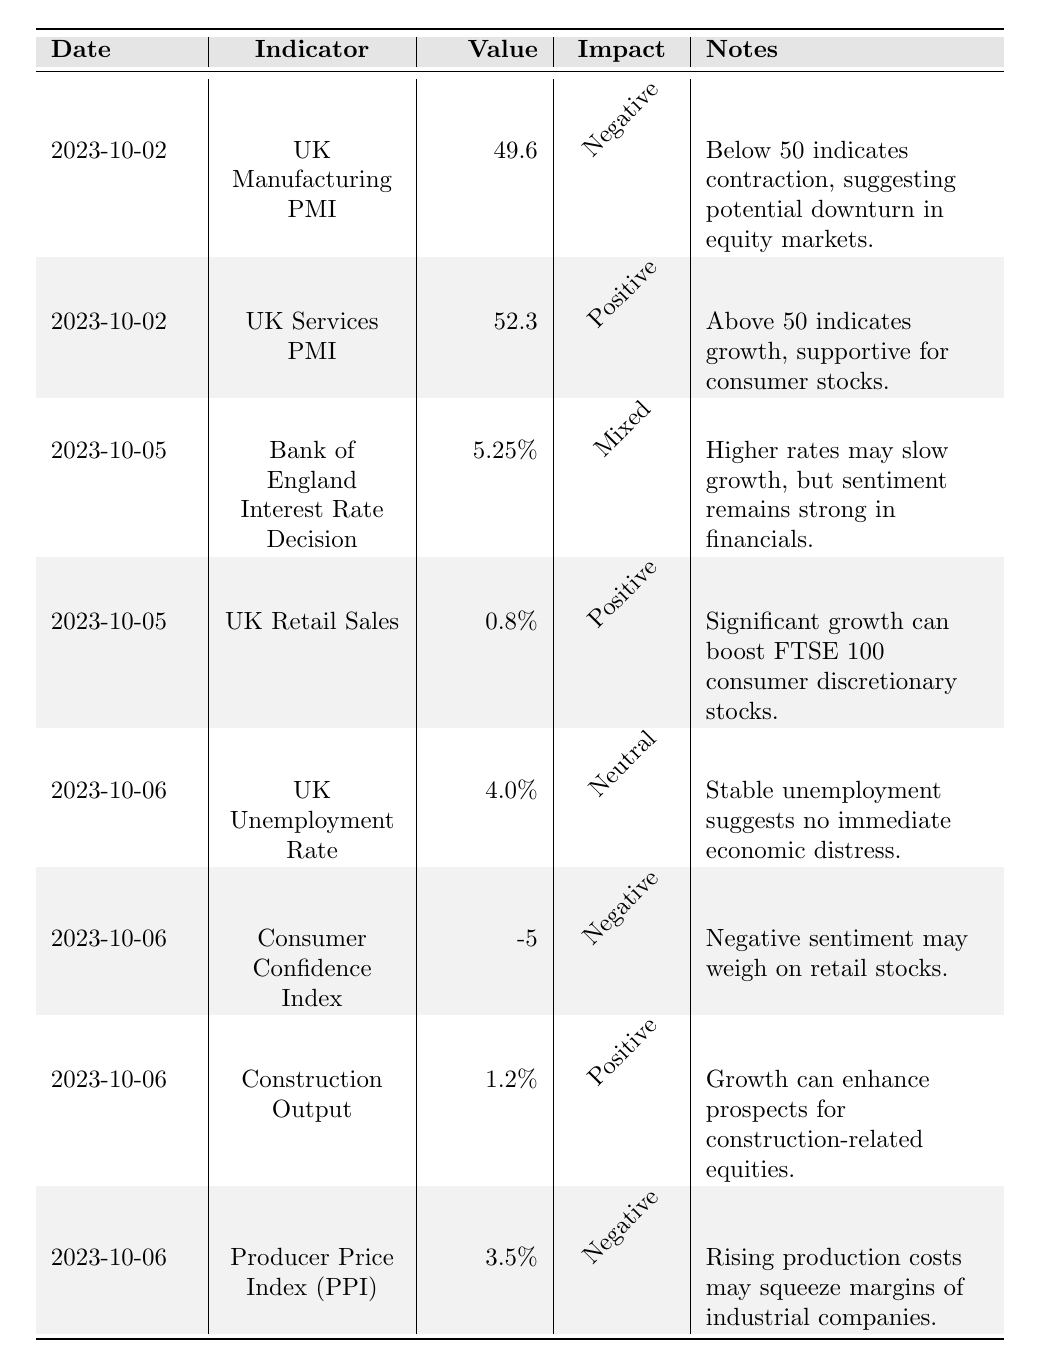What is the value of the UK Manufacturing PMI on 2023-10-02? The table shows the entry for the UK Manufacturing PMI on the date of 2023-10-02, which lists the value as 49.6.
Answer: 49.6 What impact is associated with the UK Services PMI? The table specifies that the UK Services PMI, recorded at a value of 52.3, has a positive impact.
Answer: Positive How does the UK Retail Sales figure affect the market sentiment? The value for UK Retail Sales is recorded at 0.8%, and the notes indicate this is a significant growth which can boost consumer discretionary stocks, suggesting a positive sentiment.
Answer: Positive Is the Consumer Confidence Index above zero? The Consumer Confidence Index is recorded at -5, which is below zero, indicating negative sentiment.
Answer: No What is the average value of the unemployment rate and the Producer Price Index? The unemployment rate is 4.0% and the Producer Price Index is 3.5%; to find the average, sum the two values (4.0 + 3.5) = 7.5, then divide by 2, resulting in 7.5/2 = 3.75.
Answer: 3.75 Which indicators show a positive impact on the market? The table lists the UK Services PMI, UK Retail Sales, and Construction Output, each with a positive impact noted. This means these three indicators are supportive for certain market sectors.
Answer: UK Services PMI, UK Retail Sales, Construction Output What is the relationship between the UK Manufacturing PMI and the equity markets? The table notes that the UK Manufacturing PMI value of 49.6 indicates contraction (below 50), suggesting a potential downturn in equity markets, indicating a negative relationship.
Answer: Negative relationship Which date had mixed impact due to the Bank of England Interest Rate Decision? The table identifies the Bank of England Interest Rate Decision as occurring on 2023-10-05, which had a mixed impact.
Answer: 2023-10-05 What percentage of increase does the Construction Output represent? The Construction Output is noted at 1.2%, suggesting growth which can enhance the prospects for construction-related equities, hence a positive change.
Answer: 1.2% How many indicators are listed as having a negative impact? There are three indicators with negative impacts mentioned in the notes: UK Manufacturing PMI, Consumer Confidence Index, and Producer Price Index.
Answer: 3 